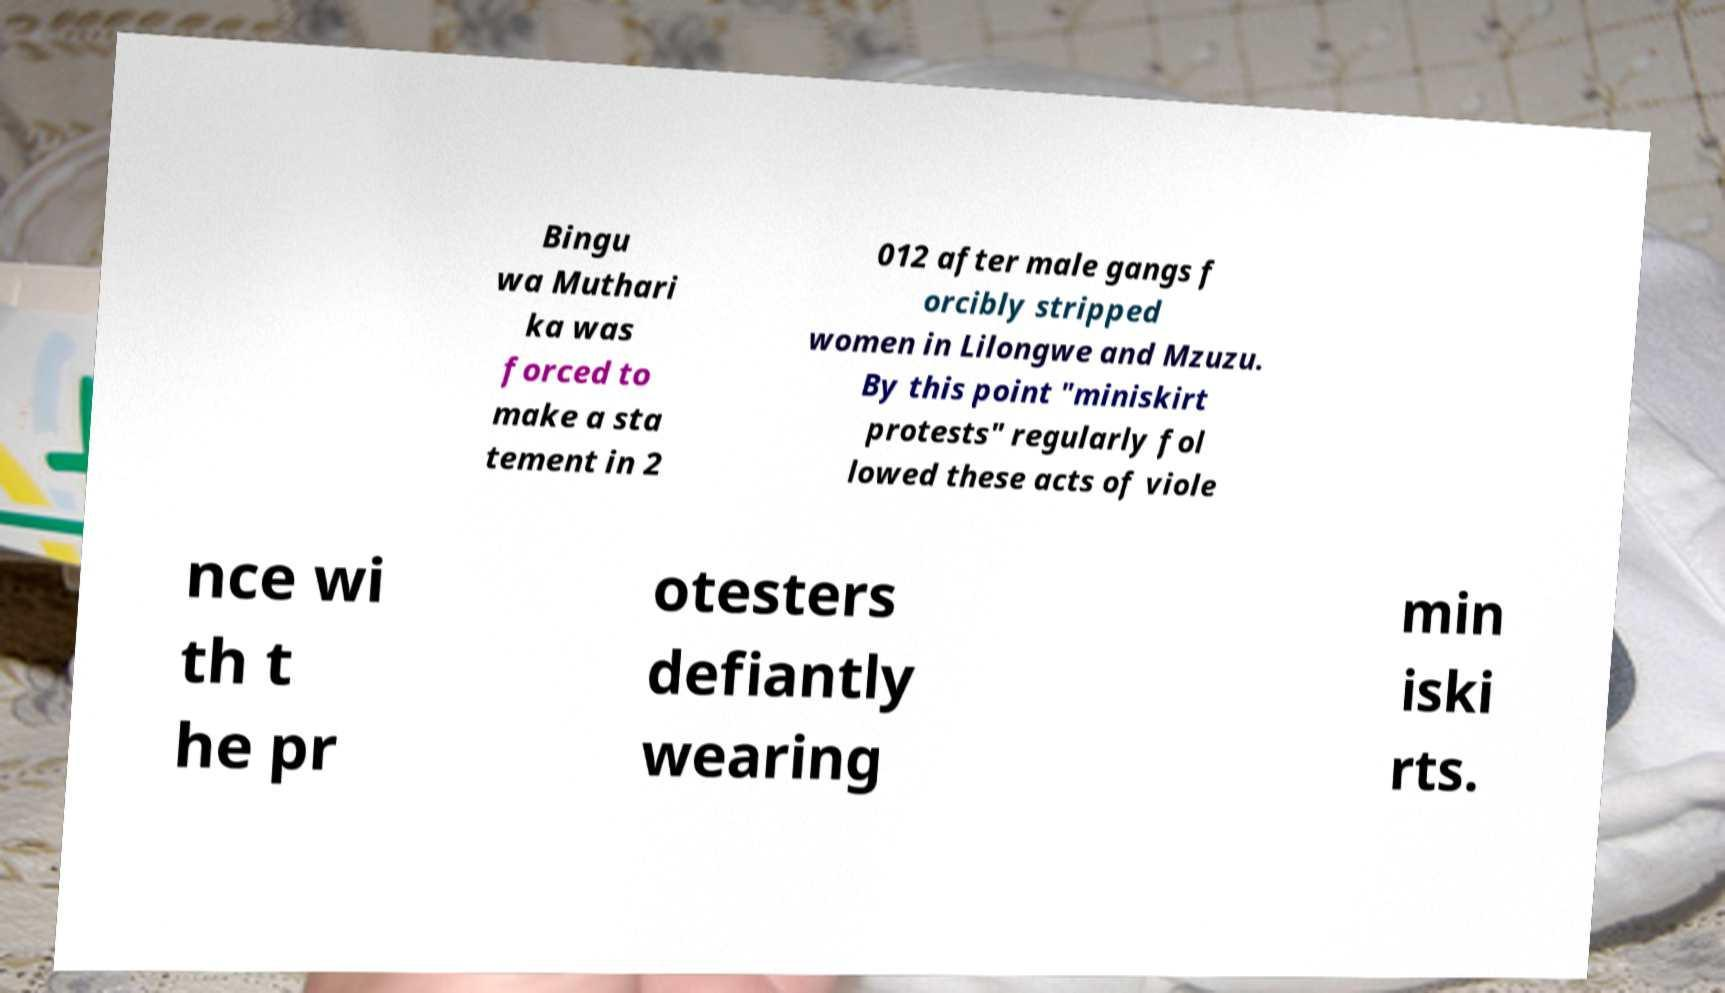Please identify and transcribe the text found in this image. Bingu wa Muthari ka was forced to make a sta tement in 2 012 after male gangs f orcibly stripped women in Lilongwe and Mzuzu. By this point "miniskirt protests" regularly fol lowed these acts of viole nce wi th t he pr otesters defiantly wearing min iski rts. 